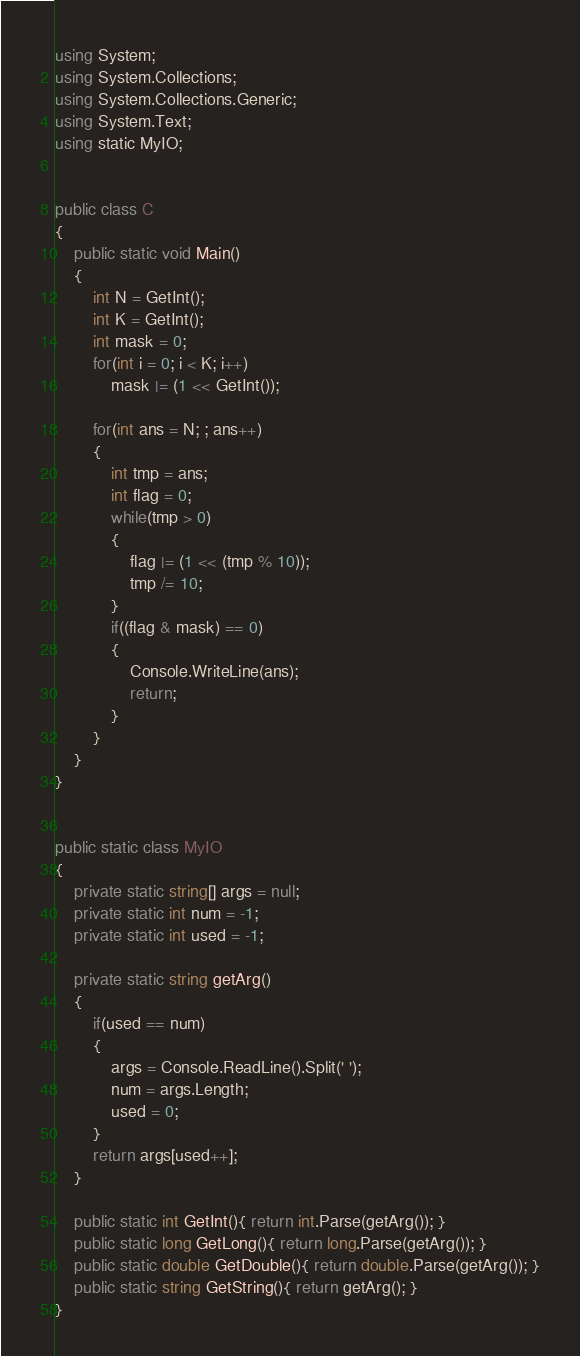<code> <loc_0><loc_0><loc_500><loc_500><_C#_>using System;
using System.Collections;
using System.Collections.Generic;
using System.Text;
using static MyIO;


public class C
{
	public static void Main()	
	{
		int N = GetInt();
		int K = GetInt();
		int mask = 0;
		for(int i = 0; i < K; i++)
			mask |= (1 << GetInt());

		for(int ans = N; ; ans++)
		{
			int tmp = ans;
			int flag = 0;
			while(tmp > 0)
			{
				flag |= (1 << (tmp % 10));
				tmp /= 10;
			}
			if((flag & mask) == 0)
			{
				Console.WriteLine(ans);
				return;
			}
		}
	}
}


public static class MyIO
{
	private static string[] args = null;
	private static int num = -1;
	private static int used = -1;

	private static string getArg()
	{
		if(used == num)
		{
			args = Console.ReadLine().Split(' ');
			num = args.Length;
			used = 0;
		}
		return args[used++];
	}

	public static int GetInt(){ return int.Parse(getArg()); }
	public static long GetLong(){ return long.Parse(getArg()); }
	public static double GetDouble(){ return double.Parse(getArg()); }
	public static string GetString(){ return getArg(); }
}
</code> 